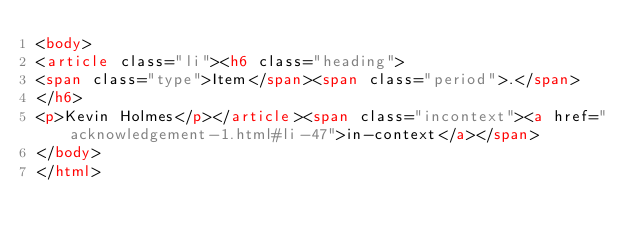<code> <loc_0><loc_0><loc_500><loc_500><_HTML_><body>
<article class="li"><h6 class="heading">
<span class="type">Item</span><span class="period">.</span>
</h6>
<p>Kevin Holmes</p></article><span class="incontext"><a href="acknowledgement-1.html#li-47">in-context</a></span>
</body>
</html>
</code> 